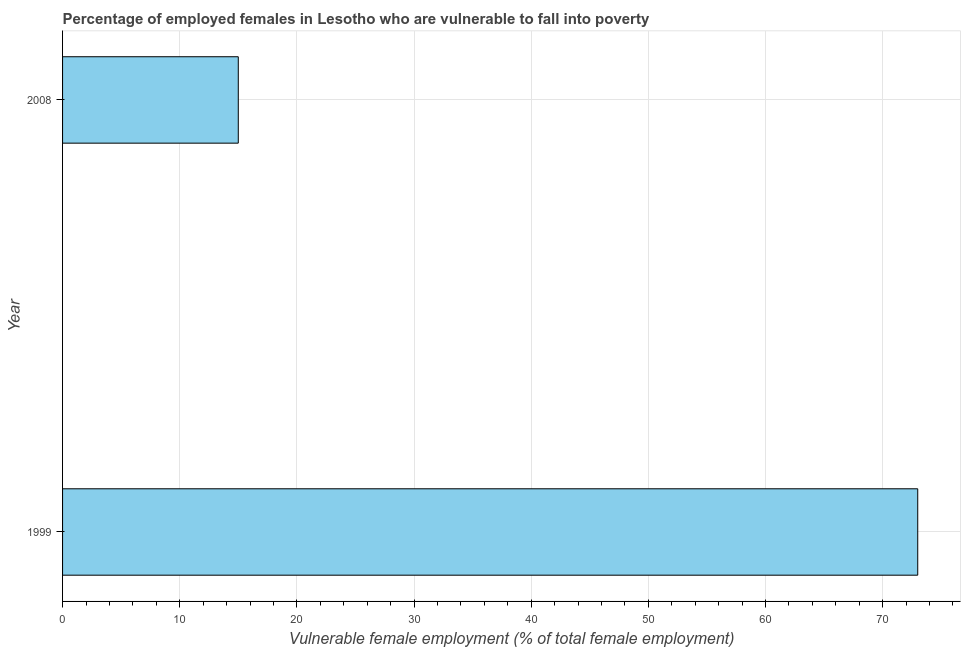Does the graph contain any zero values?
Provide a short and direct response. No. Does the graph contain grids?
Your answer should be very brief. Yes. What is the title of the graph?
Your answer should be very brief. Percentage of employed females in Lesotho who are vulnerable to fall into poverty. What is the label or title of the X-axis?
Offer a very short reply. Vulnerable female employment (% of total female employment). Across all years, what is the maximum percentage of employed females who are vulnerable to fall into poverty?
Make the answer very short. 73. Across all years, what is the minimum percentage of employed females who are vulnerable to fall into poverty?
Your response must be concise. 15. In which year was the percentage of employed females who are vulnerable to fall into poverty maximum?
Your answer should be compact. 1999. What is the difference between the percentage of employed females who are vulnerable to fall into poverty in 1999 and 2008?
Give a very brief answer. 58. What is the average percentage of employed females who are vulnerable to fall into poverty per year?
Make the answer very short. 44. What is the ratio of the percentage of employed females who are vulnerable to fall into poverty in 1999 to that in 2008?
Your answer should be very brief. 4.87. Is the percentage of employed females who are vulnerable to fall into poverty in 1999 less than that in 2008?
Ensure brevity in your answer.  No. In how many years, is the percentage of employed females who are vulnerable to fall into poverty greater than the average percentage of employed females who are vulnerable to fall into poverty taken over all years?
Keep it short and to the point. 1. How many bars are there?
Provide a succinct answer. 2. How many years are there in the graph?
Offer a terse response. 2. What is the Vulnerable female employment (% of total female employment) of 2008?
Offer a very short reply. 15. What is the ratio of the Vulnerable female employment (% of total female employment) in 1999 to that in 2008?
Provide a succinct answer. 4.87. 